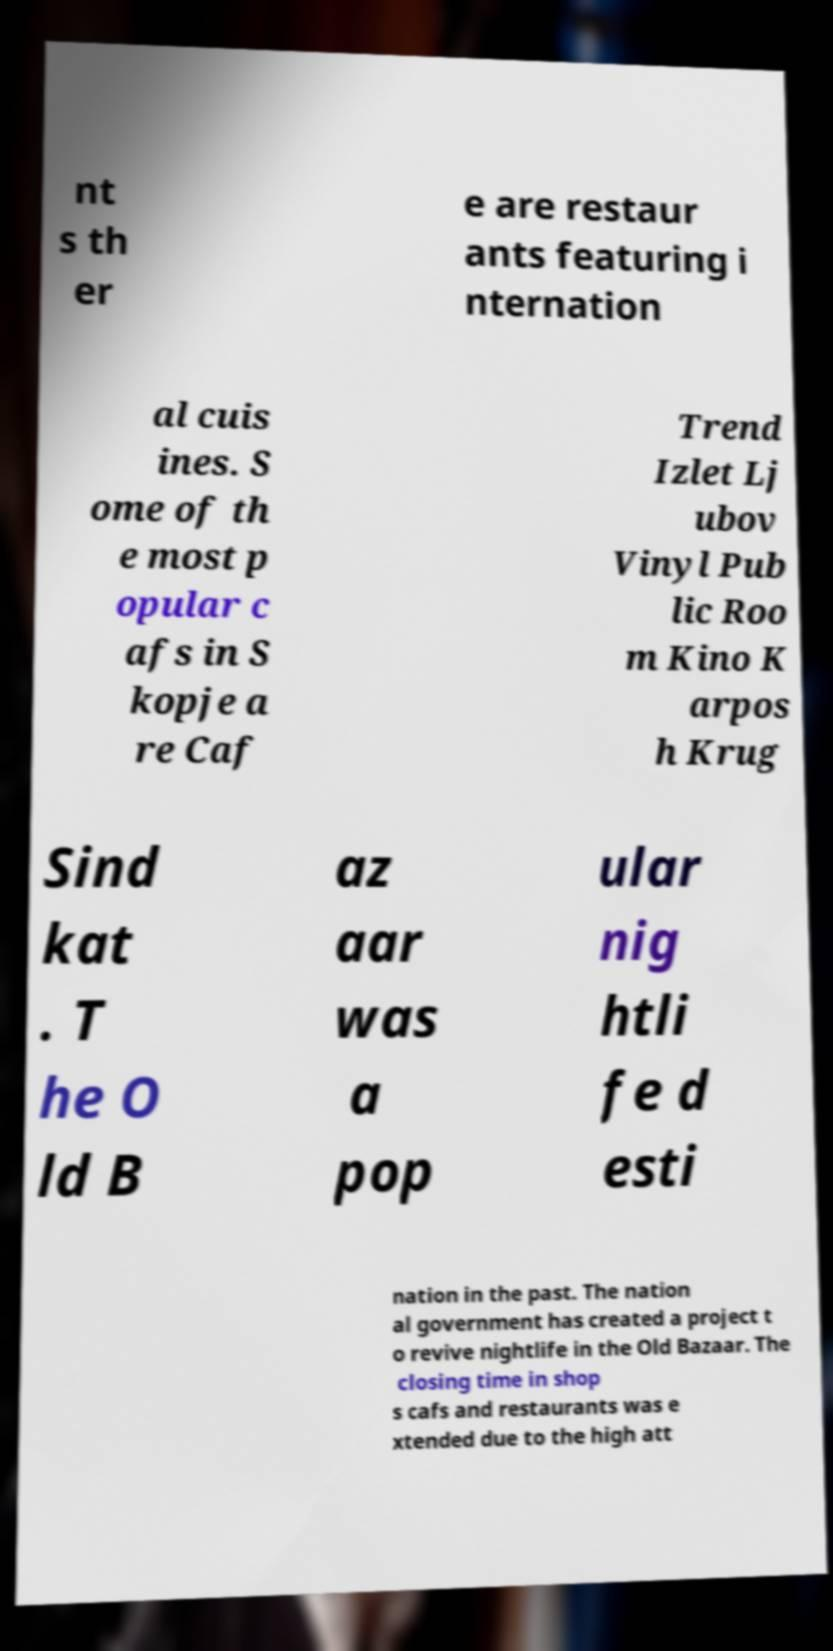What messages or text are displayed in this image? I need them in a readable, typed format. nt s th er e are restaur ants featuring i nternation al cuis ines. S ome of th e most p opular c afs in S kopje a re Caf Trend Izlet Lj ubov Vinyl Pub lic Roo m Kino K arpos h Krug Sind kat . T he O ld B az aar was a pop ular nig htli fe d esti nation in the past. The nation al government has created a project t o revive nightlife in the Old Bazaar. The closing time in shop s cafs and restaurants was e xtended due to the high att 